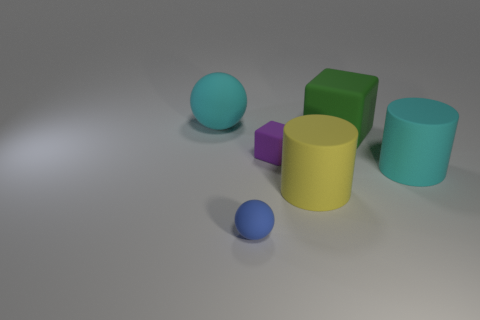Add 3 red balls. How many objects exist? 9 Subtract all cylinders. How many objects are left? 4 Add 2 large cyan matte cylinders. How many large cyan matte cylinders are left? 3 Add 5 large blue shiny objects. How many large blue shiny objects exist? 5 Subtract 1 green cubes. How many objects are left? 5 Subtract all cyan spheres. Subtract all large matte cylinders. How many objects are left? 3 